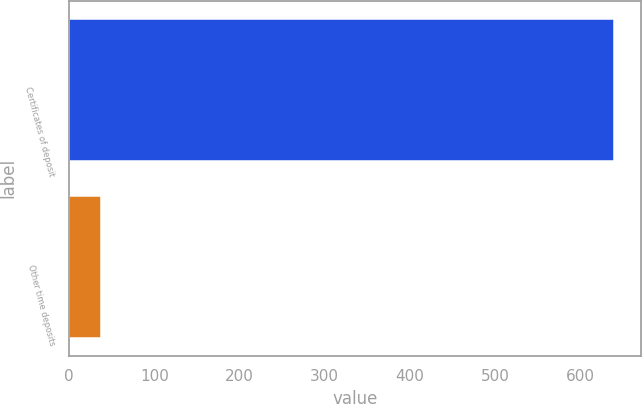<chart> <loc_0><loc_0><loc_500><loc_500><bar_chart><fcel>Certificates of deposit<fcel>Other time deposits<nl><fcel>639<fcel>37<nl></chart> 